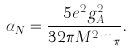Convert formula to latex. <formula><loc_0><loc_0><loc_500><loc_500>\alpha _ { N } = \frac { 5 e ^ { 2 } g _ { A } ^ { 2 } } { 3 2 \pi M ^ { 2 } m _ { \pi } } .</formula> 